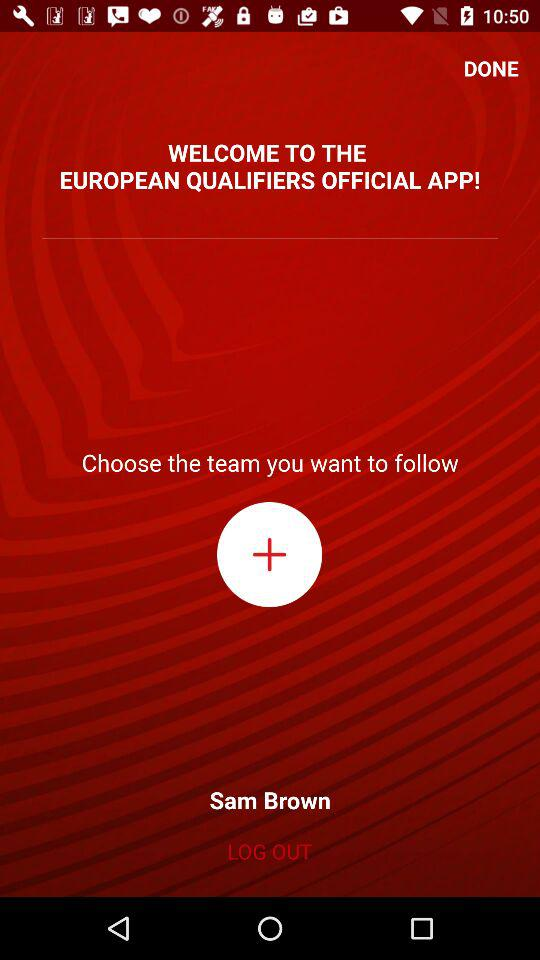What is the name of the application? The name of the application is "EUROPEAN QUALIFIERS OFFICIAL APP". 